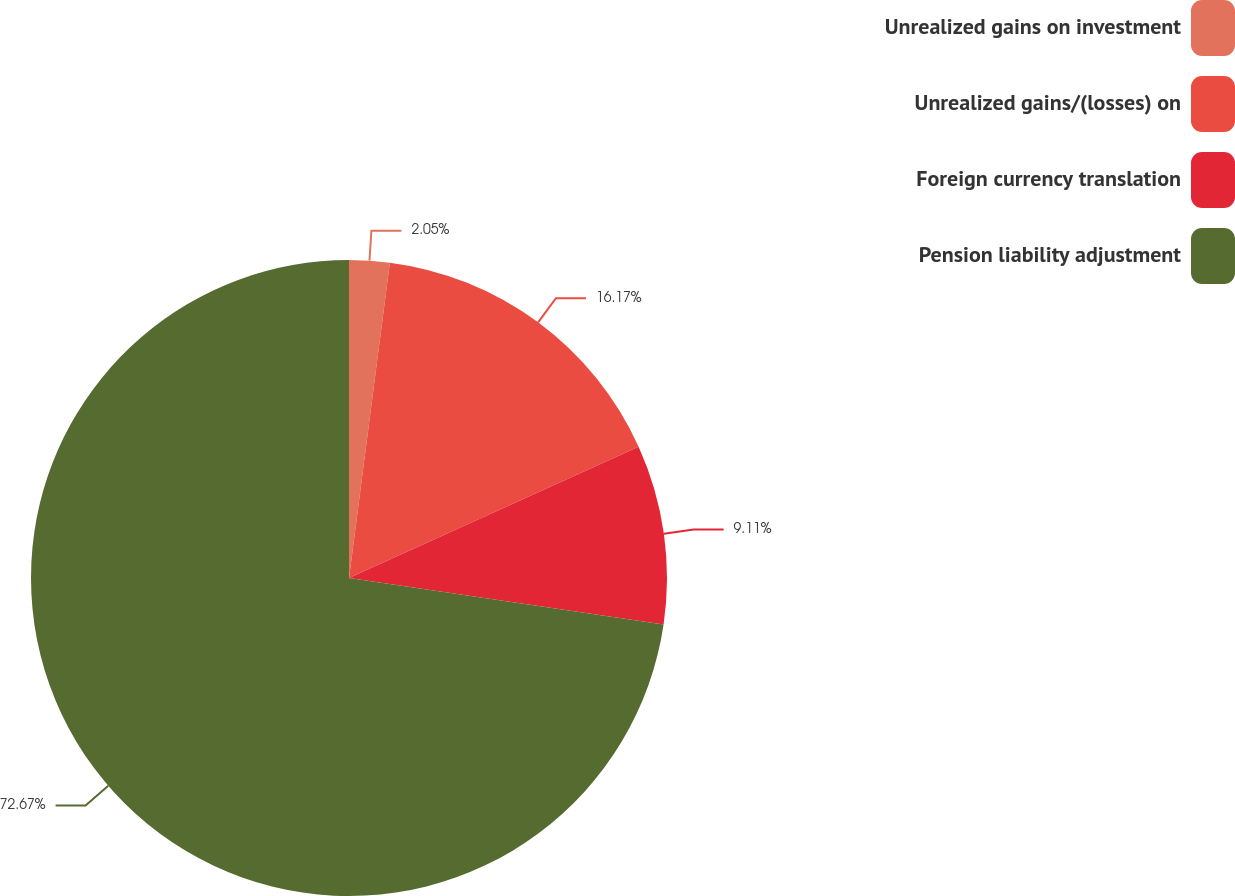Convert chart. <chart><loc_0><loc_0><loc_500><loc_500><pie_chart><fcel>Unrealized gains on investment<fcel>Unrealized gains/(losses) on<fcel>Foreign currency translation<fcel>Pension liability adjustment<nl><fcel>2.05%<fcel>16.17%<fcel>9.11%<fcel>72.66%<nl></chart> 